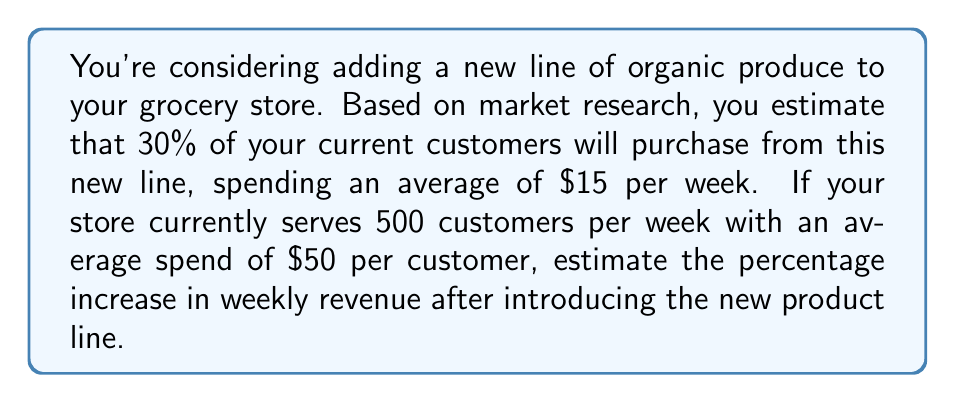Can you answer this question? Let's approach this step-by-step:

1) Calculate current weekly revenue:
   $$ \text{Current Revenue} = 500 \text{ customers} \times \$50 = \$25,000 $$

2) Calculate additional revenue from the new product line:
   Number of customers buying new products: $500 \times 30\% = 150$
   $$ \text{Additional Revenue} = 150 \text{ customers} \times \$15 = \$2,250 $$

3) Calculate new total weekly revenue:
   $$ \text{New Total Revenue} = \$25,000 + \$2,250 = \$27,250 $$

4) Calculate percentage increase:
   $$ \text{Percentage Increase} = \frac{\text{Increase}}{\text{Original}} \times 100\% $$
   $$ = \frac{\$27,250 - \$25,000}{\$25,000} \times 100\% $$
   $$ = \frac{\$2,250}{\$25,000} \times 100\% = 0.09 \times 100\% = 9\% $$

Therefore, the estimated percentage increase in weekly revenue after introducing the new product line is 9%.
Answer: 9% 